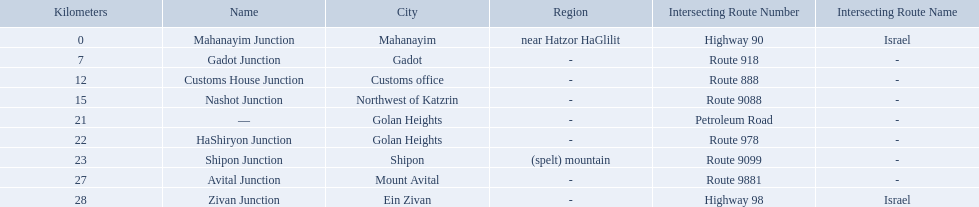What are all of the junction names? Mahanayim Junction, Gadot Junction, Customs House Junction, Nashot Junction, —, HaShiryon Junction, Shipon Junction, Avital Junction, Zivan Junction. What are their locations in kilometers? 0, 7, 12, 15, 21, 22, 23, 27, 28. Between shipon and avital, whicih is nashot closer to? Shipon Junction. Help me parse the entirety of this table. {'header': ['Kilometers', 'Name', 'City', 'Region', 'Intersecting Route Number', 'Intersecting Route Name'], 'rows': [['0', 'Mahanayim Junction', 'Mahanayim', 'near Hatzor HaGlilit', 'Highway 90', 'Israel'], ['7', 'Gadot Junction', 'Gadot', '-', 'Route 918', '-'], ['12', 'Customs House Junction', 'Customs office', '-', 'Route 888', '-'], ['15', 'Nashot Junction', 'Northwest of Katzrin', '-', 'Route 9088', '-'], ['21', '—', 'Golan Heights', '-', 'Petroleum Road', '-'], ['22', 'HaShiryon Junction', 'Golan Heights', '-', 'Route 978', '-'], ['23', 'Shipon Junction', 'Shipon', '(spelt) mountain', 'Route 9099', '-'], ['27', 'Avital Junction', 'Mount Avital', '-', 'Route 9881', '-'], ['28', 'Zivan Junction', 'Ein Zivan', '-', 'Highway 98', 'Israel']]} How many kilometers away is shipon junction? 23. How many kilometers away is avital junction? 27. Which one is closer to nashot junction? Shipon Junction. What are all the are all the locations on the highway 91 (israel)? Mahanayim, near Hatzor HaGlilit, Gadot, Customs office, Northwest of Katzrin, Golan Heights, Golan Heights, Shipon (spelt) mountain, Mount Avital, Ein Zivan. What are the distance values in kilometers for ein zivan, gadot junction and shipon junction? 7, 23, 28. Which is the least distance away? 7. What is the name? Gadot Junction. 